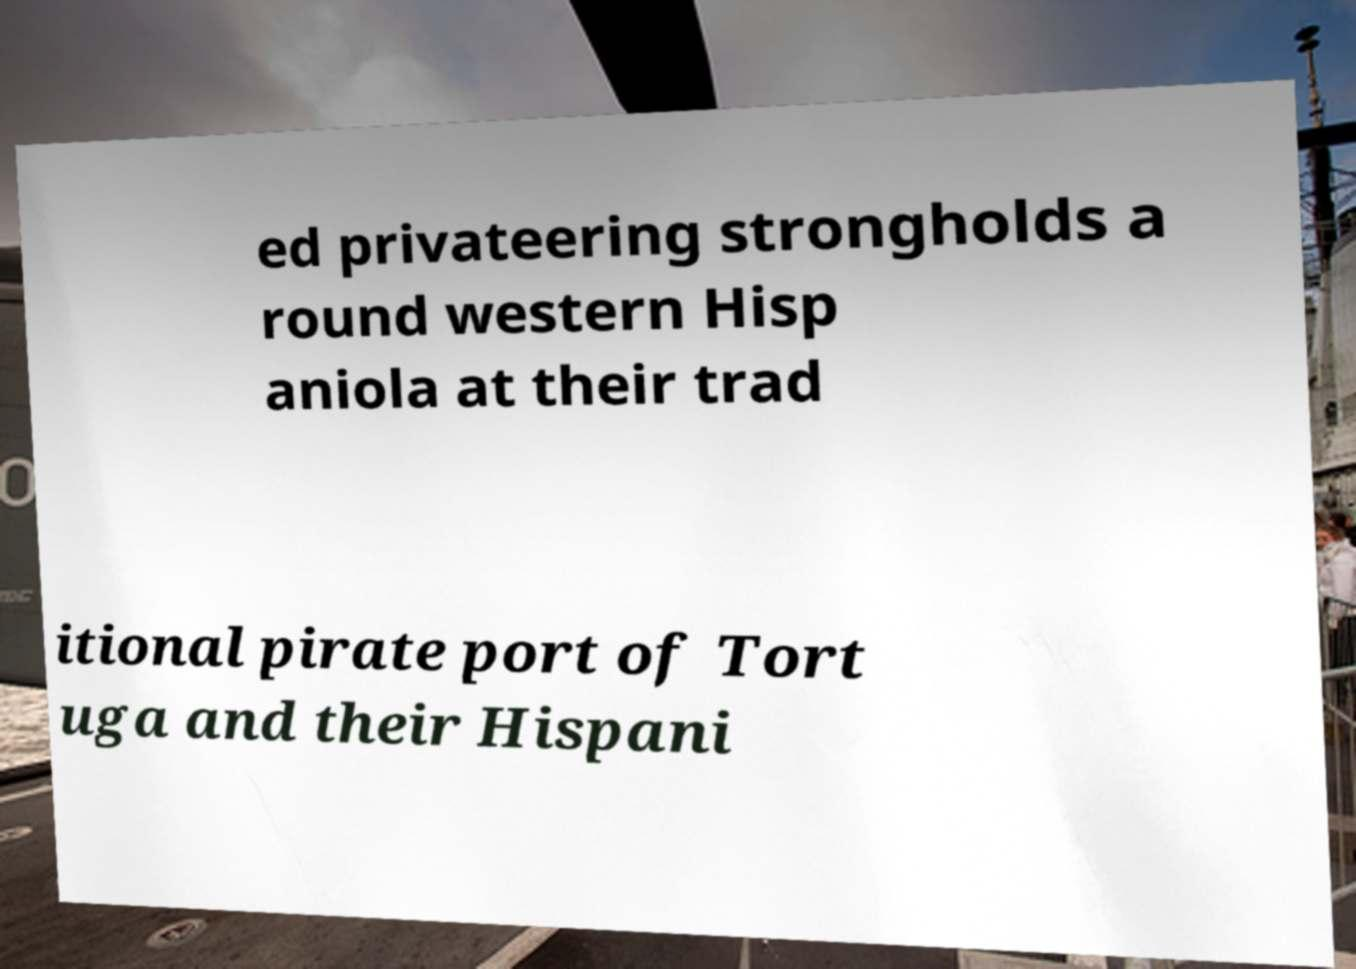There's text embedded in this image that I need extracted. Can you transcribe it verbatim? ed privateering strongholds a round western Hisp aniola at their trad itional pirate port of Tort uga and their Hispani 